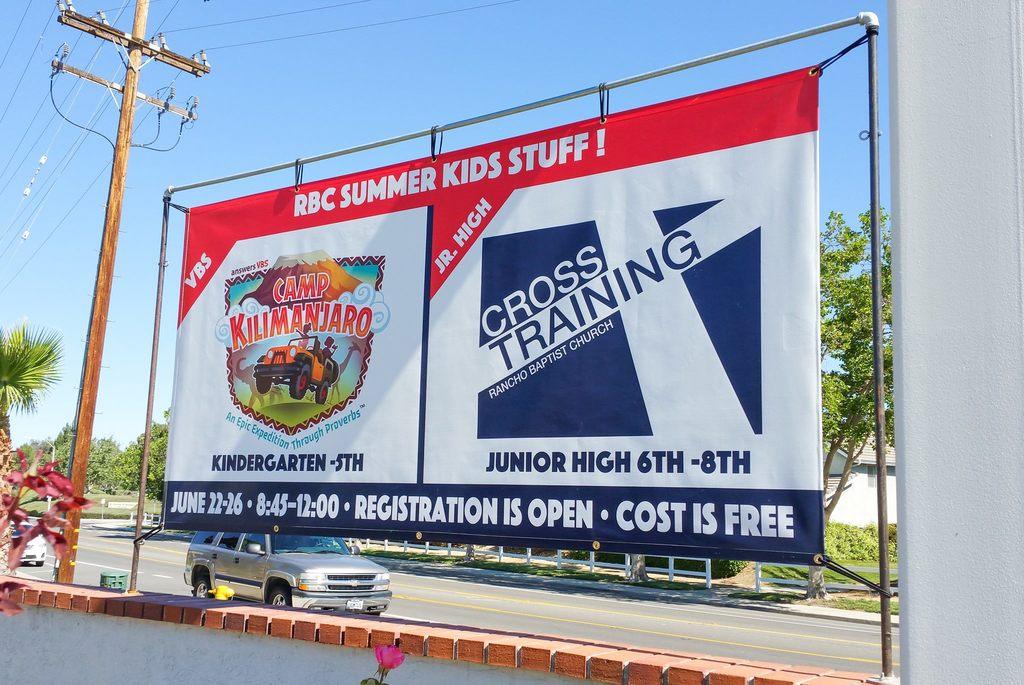What is the name of the event?
Provide a succinct answer. Camp kilimanjaro. What is the cost of this event?
Keep it short and to the point. Free. 